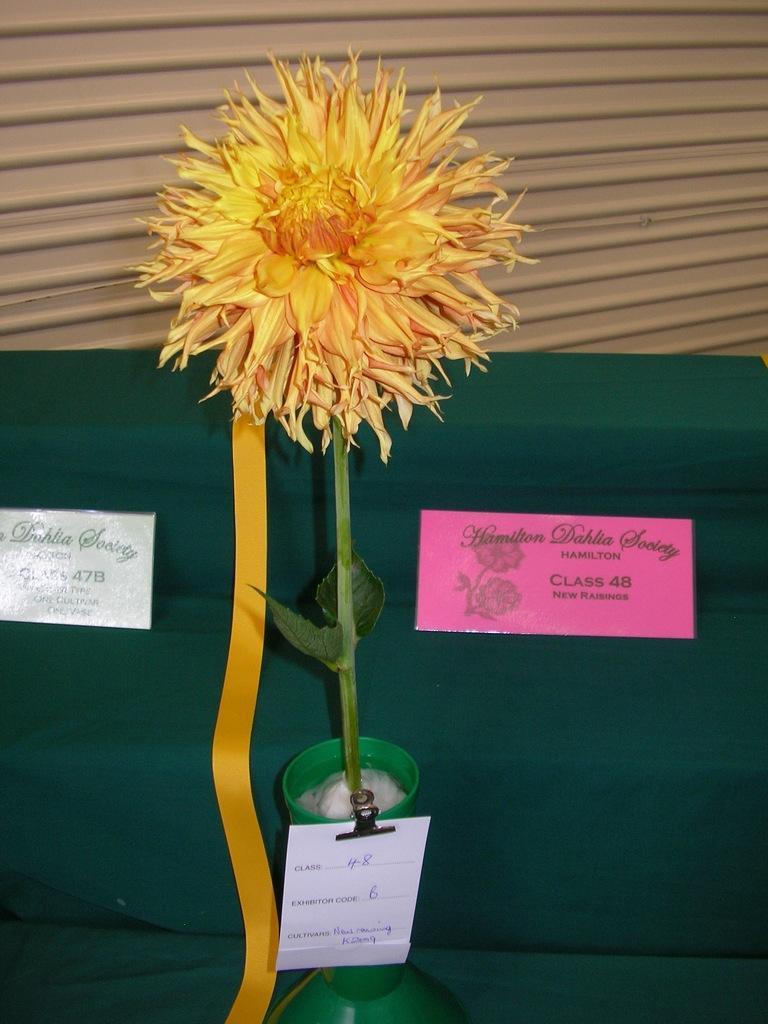Could you give a brief overview of what you see in this image? In this picture we can see a flower in a vase, boards and green cloth. In the background of the image it looks like a shutter. 